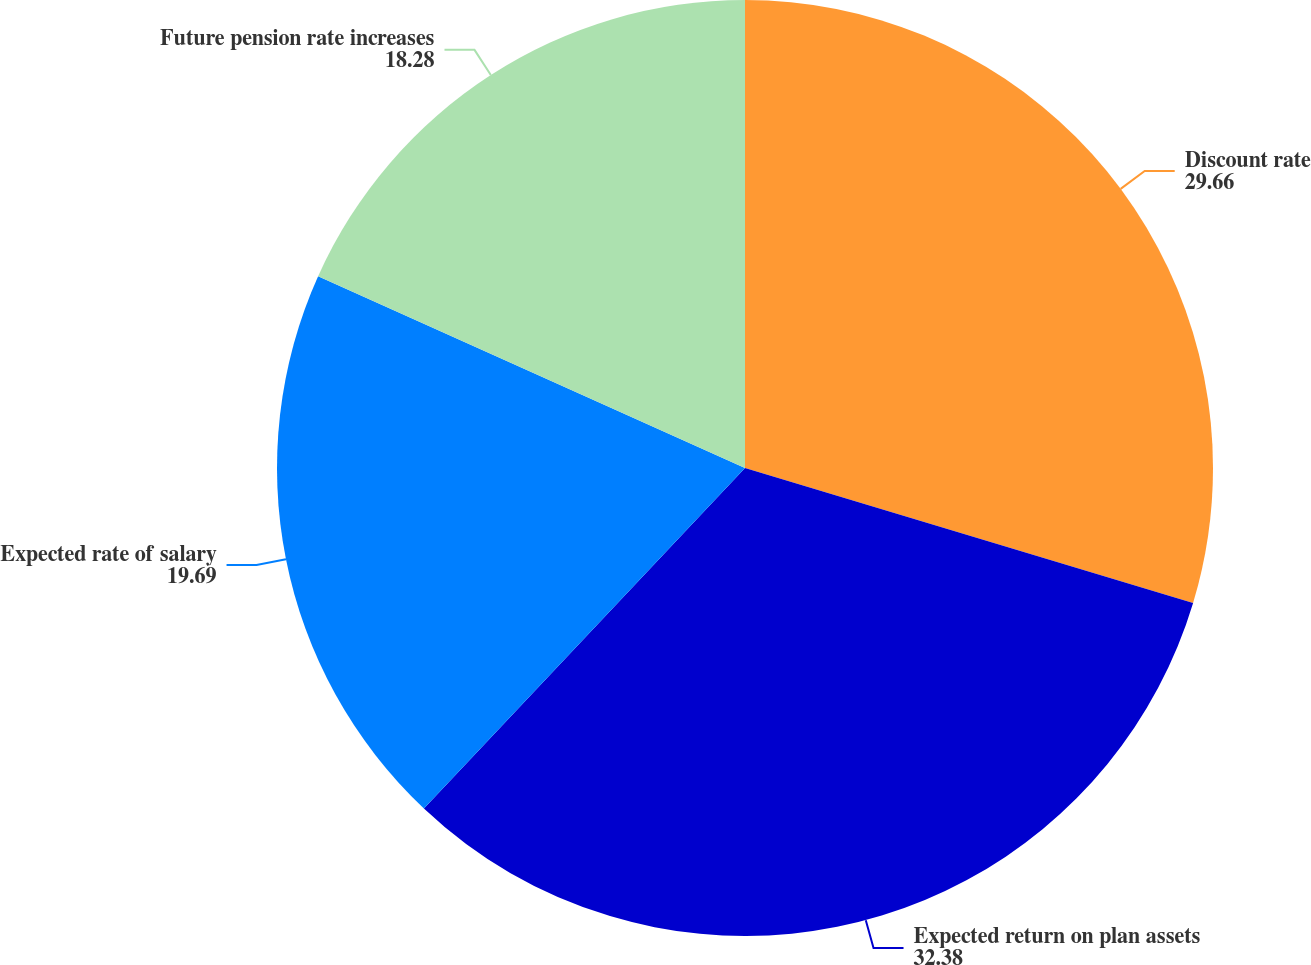<chart> <loc_0><loc_0><loc_500><loc_500><pie_chart><fcel>Discount rate<fcel>Expected return on plan assets<fcel>Expected rate of salary<fcel>Future pension rate increases<nl><fcel>29.66%<fcel>32.38%<fcel>19.69%<fcel>18.28%<nl></chart> 